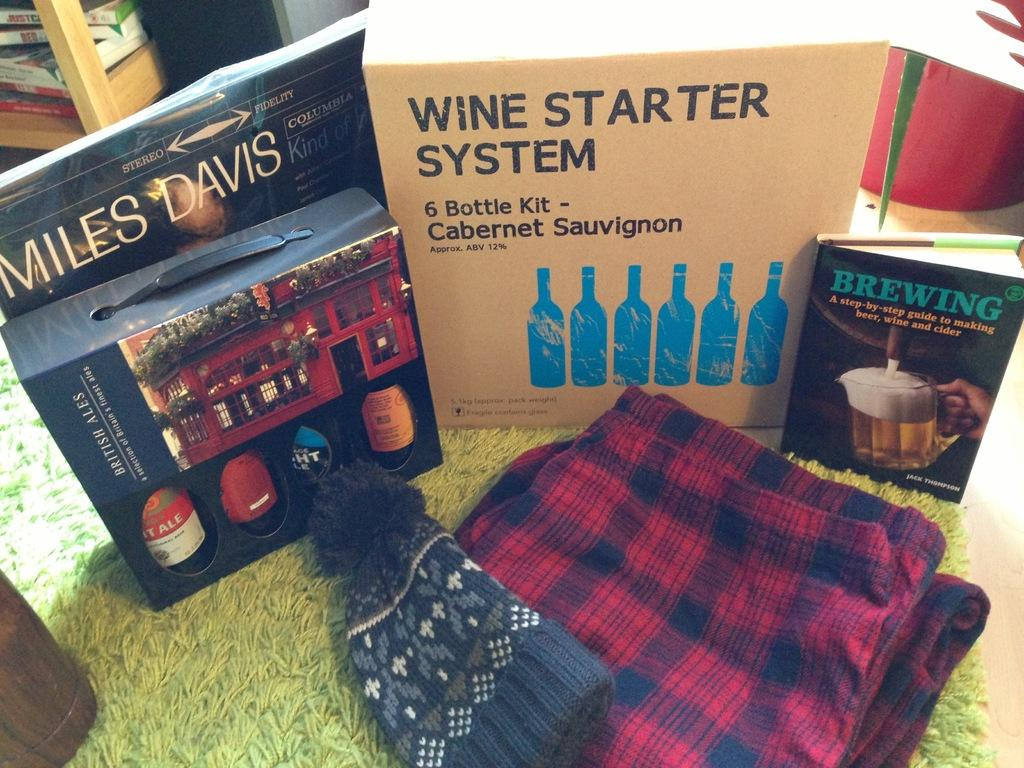<image>
Describe the image concisely. A wine starter system contains a 6 bottle kit of Cabernet Sauvignon. 